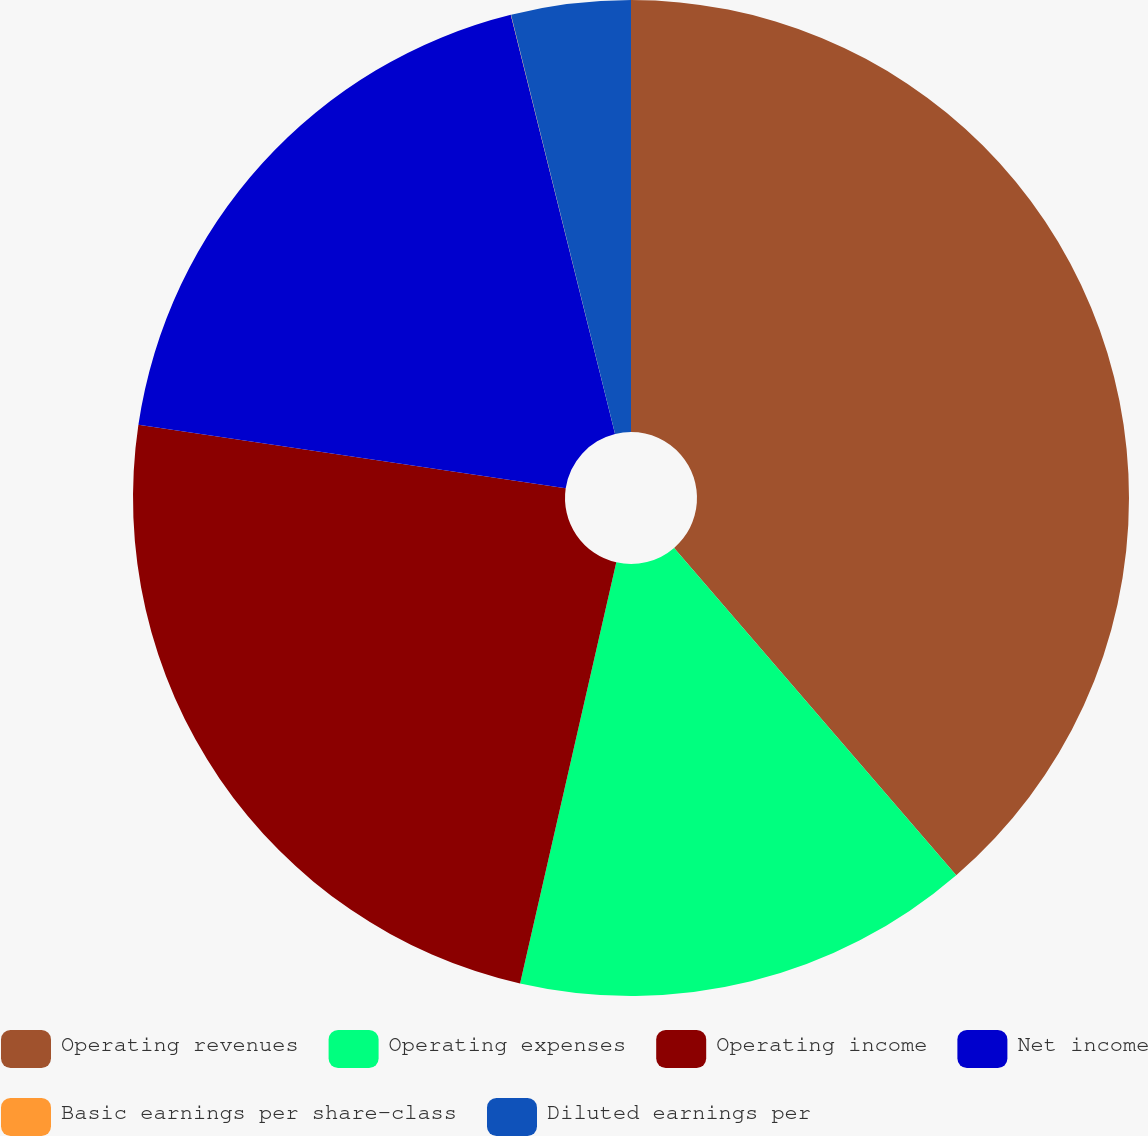Convert chart to OTSL. <chart><loc_0><loc_0><loc_500><loc_500><pie_chart><fcel>Operating revenues<fcel>Operating expenses<fcel>Operating income<fcel>Net income<fcel>Basic earnings per share-class<fcel>Diluted earnings per<nl><fcel>38.67%<fcel>14.9%<fcel>23.77%<fcel>18.77%<fcel>0.01%<fcel>3.87%<nl></chart> 